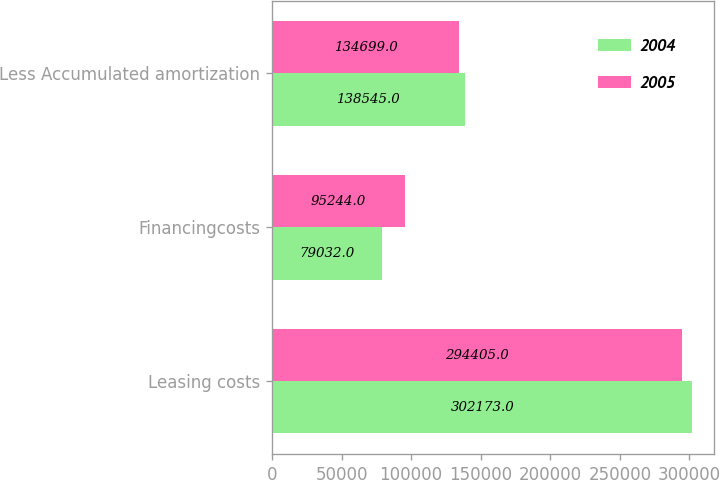<chart> <loc_0><loc_0><loc_500><loc_500><stacked_bar_chart><ecel><fcel>Leasing costs<fcel>Financingcosts<fcel>Less Accumulated amortization<nl><fcel>2004<fcel>302173<fcel>79032<fcel>138545<nl><fcel>2005<fcel>294405<fcel>95244<fcel>134699<nl></chart> 